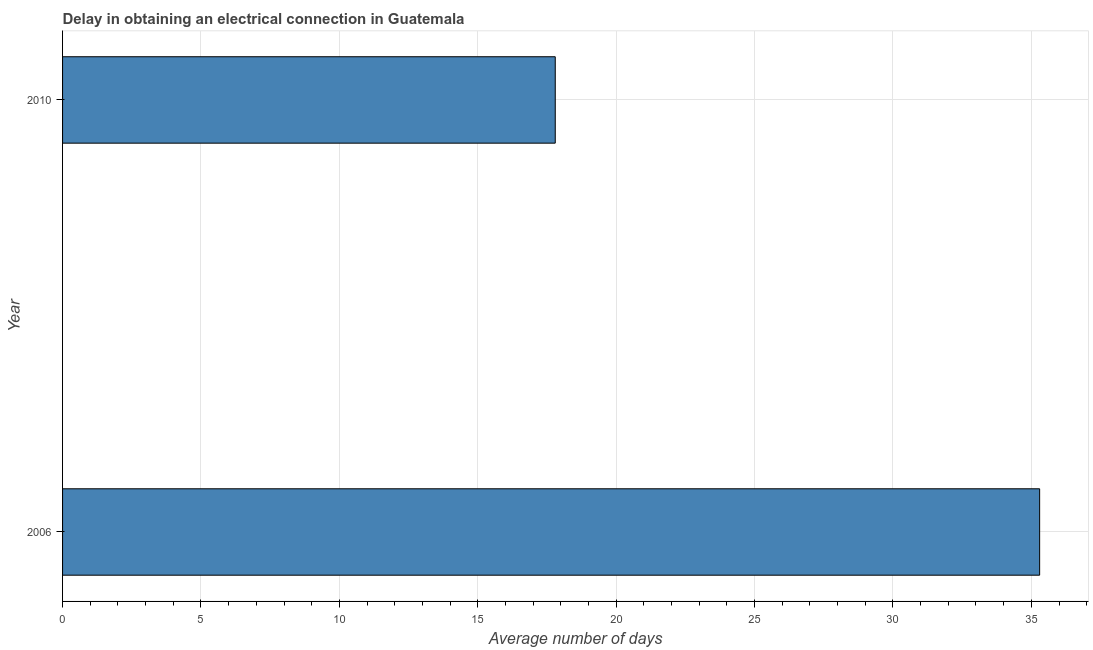Does the graph contain any zero values?
Give a very brief answer. No. Does the graph contain grids?
Offer a very short reply. Yes. What is the title of the graph?
Give a very brief answer. Delay in obtaining an electrical connection in Guatemala. What is the label or title of the X-axis?
Provide a short and direct response. Average number of days. What is the dalay in electrical connection in 2006?
Your answer should be very brief. 35.3. Across all years, what is the maximum dalay in electrical connection?
Make the answer very short. 35.3. Across all years, what is the minimum dalay in electrical connection?
Your answer should be compact. 17.8. In which year was the dalay in electrical connection maximum?
Keep it short and to the point. 2006. In which year was the dalay in electrical connection minimum?
Your response must be concise. 2010. What is the sum of the dalay in electrical connection?
Ensure brevity in your answer.  53.1. What is the difference between the dalay in electrical connection in 2006 and 2010?
Give a very brief answer. 17.5. What is the average dalay in electrical connection per year?
Your answer should be very brief. 26.55. What is the median dalay in electrical connection?
Your response must be concise. 26.55. Do a majority of the years between 2006 and 2010 (inclusive) have dalay in electrical connection greater than 29 days?
Provide a succinct answer. No. What is the ratio of the dalay in electrical connection in 2006 to that in 2010?
Keep it short and to the point. 1.98. Is the dalay in electrical connection in 2006 less than that in 2010?
Your answer should be compact. No. How many bars are there?
Make the answer very short. 2. Are all the bars in the graph horizontal?
Offer a very short reply. Yes. How many years are there in the graph?
Your answer should be very brief. 2. What is the difference between two consecutive major ticks on the X-axis?
Your answer should be very brief. 5. What is the Average number of days in 2006?
Offer a terse response. 35.3. What is the ratio of the Average number of days in 2006 to that in 2010?
Offer a terse response. 1.98. 